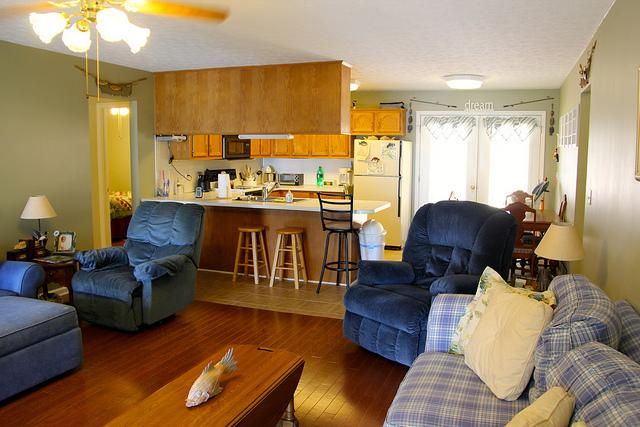What is on the brown table near the couch? fish 